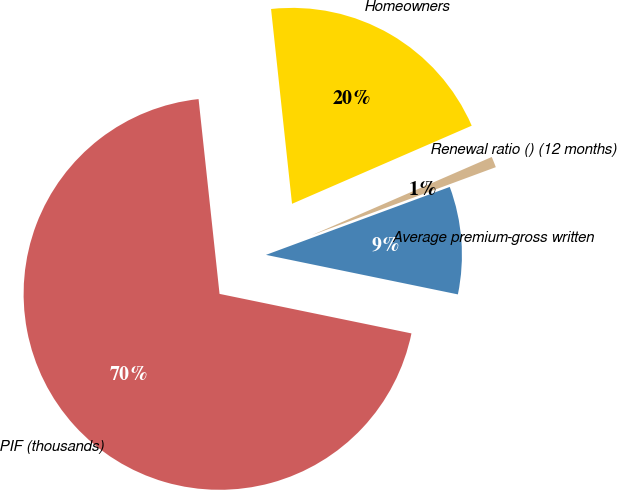Convert chart to OTSL. <chart><loc_0><loc_0><loc_500><loc_500><pie_chart><fcel>Homeowners<fcel>PIF (thousands)<fcel>Average premium-gross written<fcel>Renewal ratio () (12 months)<nl><fcel>20.18%<fcel>70.06%<fcel>8.87%<fcel>0.89%<nl></chart> 